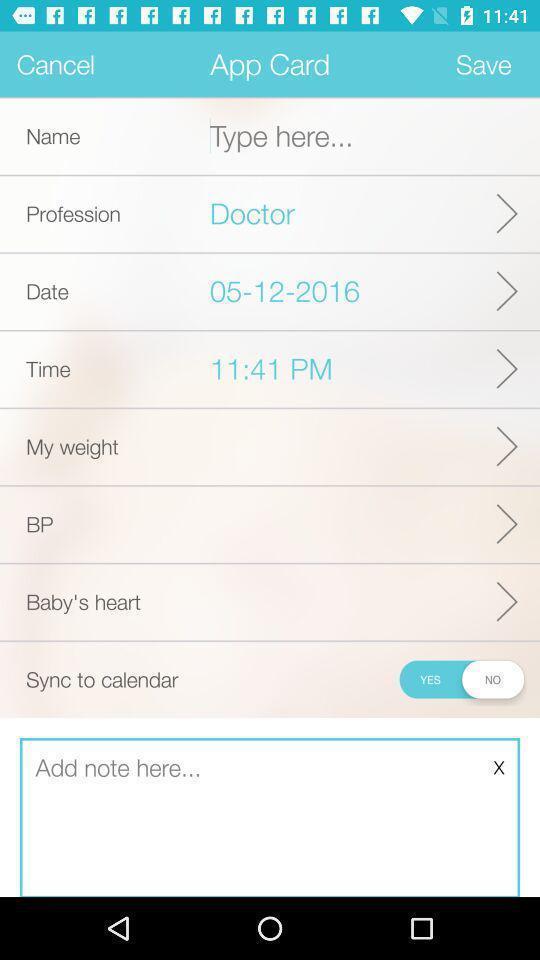Provide a textual representation of this image. Page showing different information about application. 